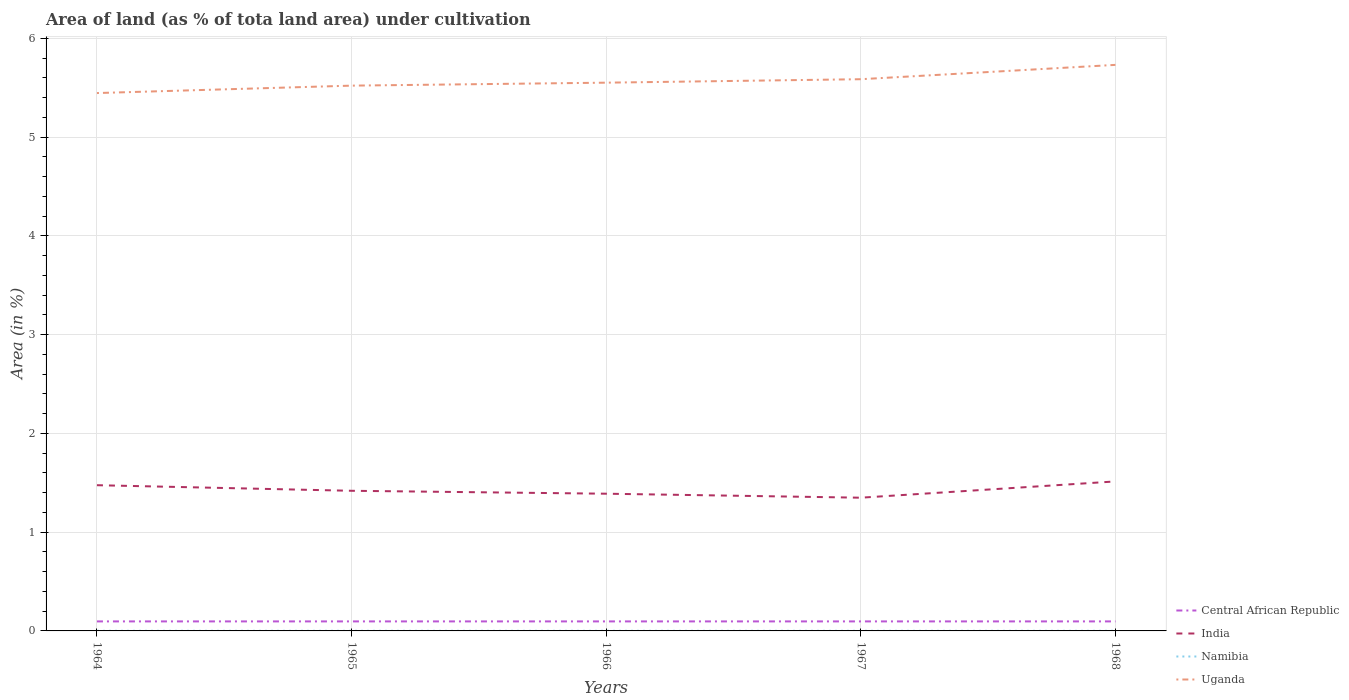Does the line corresponding to Central African Republic intersect with the line corresponding to Namibia?
Make the answer very short. No. Across all years, what is the maximum percentage of land under cultivation in Uganda?
Keep it short and to the point. 5.45. In which year was the percentage of land under cultivation in India maximum?
Give a very brief answer. 1967. What is the difference between the highest and the second highest percentage of land under cultivation in Namibia?
Provide a succinct answer. 0. Is the percentage of land under cultivation in Uganda strictly greater than the percentage of land under cultivation in Central African Republic over the years?
Provide a short and direct response. No. What is the difference between two consecutive major ticks on the Y-axis?
Your response must be concise. 1. Does the graph contain grids?
Ensure brevity in your answer.  Yes. How many legend labels are there?
Your answer should be very brief. 4. What is the title of the graph?
Your answer should be compact. Area of land (as % of tota land area) under cultivation. Does "Russian Federation" appear as one of the legend labels in the graph?
Provide a succinct answer. No. What is the label or title of the X-axis?
Provide a succinct answer. Years. What is the label or title of the Y-axis?
Offer a very short reply. Area (in %). What is the Area (in %) of Central African Republic in 1964?
Provide a succinct answer. 0.1. What is the Area (in %) of India in 1964?
Provide a short and direct response. 1.48. What is the Area (in %) in Namibia in 1964?
Your answer should be very brief. 0. What is the Area (in %) of Uganda in 1964?
Make the answer very short. 5.45. What is the Area (in %) in Central African Republic in 1965?
Offer a very short reply. 0.1. What is the Area (in %) of India in 1965?
Make the answer very short. 1.42. What is the Area (in %) in Namibia in 1965?
Provide a short and direct response. 0. What is the Area (in %) of Uganda in 1965?
Keep it short and to the point. 5.52. What is the Area (in %) in Central African Republic in 1966?
Offer a terse response. 0.1. What is the Area (in %) of India in 1966?
Provide a succinct answer. 1.39. What is the Area (in %) of Namibia in 1966?
Offer a terse response. 0. What is the Area (in %) in Uganda in 1966?
Offer a very short reply. 5.55. What is the Area (in %) of Central African Republic in 1967?
Give a very brief answer. 0.1. What is the Area (in %) in India in 1967?
Offer a terse response. 1.35. What is the Area (in %) of Namibia in 1967?
Make the answer very short. 0. What is the Area (in %) in Uganda in 1967?
Provide a short and direct response. 5.59. What is the Area (in %) in Central African Republic in 1968?
Give a very brief answer. 0.1. What is the Area (in %) in India in 1968?
Keep it short and to the point. 1.51. What is the Area (in %) of Namibia in 1968?
Your answer should be compact. 0. What is the Area (in %) in Uganda in 1968?
Ensure brevity in your answer.  5.73. Across all years, what is the maximum Area (in %) of Central African Republic?
Ensure brevity in your answer.  0.1. Across all years, what is the maximum Area (in %) in India?
Ensure brevity in your answer.  1.51. Across all years, what is the maximum Area (in %) of Namibia?
Ensure brevity in your answer.  0. Across all years, what is the maximum Area (in %) of Uganda?
Give a very brief answer. 5.73. Across all years, what is the minimum Area (in %) in Central African Republic?
Offer a very short reply. 0.1. Across all years, what is the minimum Area (in %) in India?
Your response must be concise. 1.35. Across all years, what is the minimum Area (in %) in Namibia?
Make the answer very short. 0. Across all years, what is the minimum Area (in %) of Uganda?
Provide a succinct answer. 5.45. What is the total Area (in %) in Central African Republic in the graph?
Give a very brief answer. 0.48. What is the total Area (in %) in India in the graph?
Offer a terse response. 7.15. What is the total Area (in %) in Namibia in the graph?
Ensure brevity in your answer.  0.01. What is the total Area (in %) of Uganda in the graph?
Provide a short and direct response. 27.83. What is the difference between the Area (in %) of India in 1964 and that in 1965?
Your response must be concise. 0.06. What is the difference between the Area (in %) of Namibia in 1964 and that in 1965?
Your answer should be compact. 0. What is the difference between the Area (in %) in Uganda in 1964 and that in 1965?
Provide a short and direct response. -0.08. What is the difference between the Area (in %) of India in 1964 and that in 1966?
Make the answer very short. 0.09. What is the difference between the Area (in %) of Uganda in 1964 and that in 1966?
Offer a terse response. -0.11. What is the difference between the Area (in %) of Central African Republic in 1964 and that in 1967?
Your answer should be very brief. 0. What is the difference between the Area (in %) of India in 1964 and that in 1967?
Offer a very short reply. 0.13. What is the difference between the Area (in %) of Namibia in 1964 and that in 1967?
Offer a terse response. 0. What is the difference between the Area (in %) in Uganda in 1964 and that in 1967?
Make the answer very short. -0.14. What is the difference between the Area (in %) of India in 1964 and that in 1968?
Offer a very short reply. -0.04. What is the difference between the Area (in %) in Namibia in 1964 and that in 1968?
Provide a succinct answer. 0. What is the difference between the Area (in %) in Uganda in 1964 and that in 1968?
Keep it short and to the point. -0.29. What is the difference between the Area (in %) of Central African Republic in 1965 and that in 1966?
Make the answer very short. 0. What is the difference between the Area (in %) in India in 1965 and that in 1966?
Your response must be concise. 0.03. What is the difference between the Area (in %) in Uganda in 1965 and that in 1966?
Keep it short and to the point. -0.03. What is the difference between the Area (in %) of Central African Republic in 1965 and that in 1967?
Ensure brevity in your answer.  0. What is the difference between the Area (in %) in India in 1965 and that in 1967?
Provide a succinct answer. 0.07. What is the difference between the Area (in %) of Uganda in 1965 and that in 1967?
Give a very brief answer. -0.07. What is the difference between the Area (in %) of India in 1965 and that in 1968?
Make the answer very short. -0.09. What is the difference between the Area (in %) in Uganda in 1965 and that in 1968?
Make the answer very short. -0.21. What is the difference between the Area (in %) of India in 1966 and that in 1967?
Your answer should be very brief. 0.04. What is the difference between the Area (in %) of Namibia in 1966 and that in 1967?
Offer a terse response. 0. What is the difference between the Area (in %) in Uganda in 1966 and that in 1967?
Offer a terse response. -0.04. What is the difference between the Area (in %) in India in 1966 and that in 1968?
Offer a terse response. -0.12. What is the difference between the Area (in %) in Namibia in 1966 and that in 1968?
Offer a very short reply. 0. What is the difference between the Area (in %) of Uganda in 1966 and that in 1968?
Your answer should be very brief. -0.18. What is the difference between the Area (in %) in India in 1967 and that in 1968?
Ensure brevity in your answer.  -0.16. What is the difference between the Area (in %) of Namibia in 1967 and that in 1968?
Make the answer very short. 0. What is the difference between the Area (in %) of Uganda in 1967 and that in 1968?
Your response must be concise. -0.15. What is the difference between the Area (in %) of Central African Republic in 1964 and the Area (in %) of India in 1965?
Ensure brevity in your answer.  -1.32. What is the difference between the Area (in %) of Central African Republic in 1964 and the Area (in %) of Namibia in 1965?
Keep it short and to the point. 0.1. What is the difference between the Area (in %) in Central African Republic in 1964 and the Area (in %) in Uganda in 1965?
Your response must be concise. -5.42. What is the difference between the Area (in %) in India in 1964 and the Area (in %) in Namibia in 1965?
Keep it short and to the point. 1.47. What is the difference between the Area (in %) of India in 1964 and the Area (in %) of Uganda in 1965?
Keep it short and to the point. -4.05. What is the difference between the Area (in %) of Namibia in 1964 and the Area (in %) of Uganda in 1965?
Offer a terse response. -5.52. What is the difference between the Area (in %) of Central African Republic in 1964 and the Area (in %) of India in 1966?
Ensure brevity in your answer.  -1.29. What is the difference between the Area (in %) of Central African Republic in 1964 and the Area (in %) of Namibia in 1966?
Your answer should be very brief. 0.1. What is the difference between the Area (in %) of Central African Republic in 1964 and the Area (in %) of Uganda in 1966?
Ensure brevity in your answer.  -5.45. What is the difference between the Area (in %) in India in 1964 and the Area (in %) in Namibia in 1966?
Provide a succinct answer. 1.47. What is the difference between the Area (in %) in India in 1964 and the Area (in %) in Uganda in 1966?
Make the answer very short. -4.08. What is the difference between the Area (in %) in Namibia in 1964 and the Area (in %) in Uganda in 1966?
Provide a short and direct response. -5.55. What is the difference between the Area (in %) in Central African Republic in 1964 and the Area (in %) in India in 1967?
Your answer should be compact. -1.25. What is the difference between the Area (in %) of Central African Republic in 1964 and the Area (in %) of Namibia in 1967?
Keep it short and to the point. 0.1. What is the difference between the Area (in %) of Central African Republic in 1964 and the Area (in %) of Uganda in 1967?
Ensure brevity in your answer.  -5.49. What is the difference between the Area (in %) in India in 1964 and the Area (in %) in Namibia in 1967?
Make the answer very short. 1.47. What is the difference between the Area (in %) of India in 1964 and the Area (in %) of Uganda in 1967?
Your answer should be compact. -4.11. What is the difference between the Area (in %) in Namibia in 1964 and the Area (in %) in Uganda in 1967?
Your response must be concise. -5.58. What is the difference between the Area (in %) of Central African Republic in 1964 and the Area (in %) of India in 1968?
Give a very brief answer. -1.42. What is the difference between the Area (in %) of Central African Republic in 1964 and the Area (in %) of Namibia in 1968?
Provide a succinct answer. 0.1. What is the difference between the Area (in %) of Central African Republic in 1964 and the Area (in %) of Uganda in 1968?
Give a very brief answer. -5.63. What is the difference between the Area (in %) of India in 1964 and the Area (in %) of Namibia in 1968?
Your answer should be compact. 1.47. What is the difference between the Area (in %) of India in 1964 and the Area (in %) of Uganda in 1968?
Ensure brevity in your answer.  -4.26. What is the difference between the Area (in %) in Namibia in 1964 and the Area (in %) in Uganda in 1968?
Offer a very short reply. -5.73. What is the difference between the Area (in %) of Central African Republic in 1965 and the Area (in %) of India in 1966?
Offer a terse response. -1.29. What is the difference between the Area (in %) of Central African Republic in 1965 and the Area (in %) of Namibia in 1966?
Provide a short and direct response. 0.1. What is the difference between the Area (in %) in Central African Republic in 1965 and the Area (in %) in Uganda in 1966?
Offer a very short reply. -5.45. What is the difference between the Area (in %) of India in 1965 and the Area (in %) of Namibia in 1966?
Your answer should be compact. 1.42. What is the difference between the Area (in %) of India in 1965 and the Area (in %) of Uganda in 1966?
Your response must be concise. -4.13. What is the difference between the Area (in %) of Namibia in 1965 and the Area (in %) of Uganda in 1966?
Provide a succinct answer. -5.55. What is the difference between the Area (in %) of Central African Republic in 1965 and the Area (in %) of India in 1967?
Your answer should be compact. -1.25. What is the difference between the Area (in %) of Central African Republic in 1965 and the Area (in %) of Namibia in 1967?
Keep it short and to the point. 0.1. What is the difference between the Area (in %) of Central African Republic in 1965 and the Area (in %) of Uganda in 1967?
Offer a very short reply. -5.49. What is the difference between the Area (in %) of India in 1965 and the Area (in %) of Namibia in 1967?
Provide a succinct answer. 1.42. What is the difference between the Area (in %) in India in 1965 and the Area (in %) in Uganda in 1967?
Your answer should be compact. -4.17. What is the difference between the Area (in %) of Namibia in 1965 and the Area (in %) of Uganda in 1967?
Offer a very short reply. -5.58. What is the difference between the Area (in %) in Central African Republic in 1965 and the Area (in %) in India in 1968?
Provide a short and direct response. -1.42. What is the difference between the Area (in %) of Central African Republic in 1965 and the Area (in %) of Namibia in 1968?
Give a very brief answer. 0.1. What is the difference between the Area (in %) in Central African Republic in 1965 and the Area (in %) in Uganda in 1968?
Your answer should be very brief. -5.63. What is the difference between the Area (in %) in India in 1965 and the Area (in %) in Namibia in 1968?
Provide a succinct answer. 1.42. What is the difference between the Area (in %) in India in 1965 and the Area (in %) in Uganda in 1968?
Make the answer very short. -4.31. What is the difference between the Area (in %) of Namibia in 1965 and the Area (in %) of Uganda in 1968?
Make the answer very short. -5.73. What is the difference between the Area (in %) of Central African Republic in 1966 and the Area (in %) of India in 1967?
Your answer should be compact. -1.25. What is the difference between the Area (in %) in Central African Republic in 1966 and the Area (in %) in Namibia in 1967?
Provide a short and direct response. 0.1. What is the difference between the Area (in %) in Central African Republic in 1966 and the Area (in %) in Uganda in 1967?
Your answer should be very brief. -5.49. What is the difference between the Area (in %) in India in 1966 and the Area (in %) in Namibia in 1967?
Your answer should be very brief. 1.39. What is the difference between the Area (in %) in India in 1966 and the Area (in %) in Uganda in 1967?
Your answer should be very brief. -4.2. What is the difference between the Area (in %) of Namibia in 1966 and the Area (in %) of Uganda in 1967?
Provide a succinct answer. -5.58. What is the difference between the Area (in %) in Central African Republic in 1966 and the Area (in %) in India in 1968?
Make the answer very short. -1.42. What is the difference between the Area (in %) of Central African Republic in 1966 and the Area (in %) of Namibia in 1968?
Offer a terse response. 0.1. What is the difference between the Area (in %) in Central African Republic in 1966 and the Area (in %) in Uganda in 1968?
Ensure brevity in your answer.  -5.63. What is the difference between the Area (in %) in India in 1966 and the Area (in %) in Namibia in 1968?
Offer a terse response. 1.39. What is the difference between the Area (in %) in India in 1966 and the Area (in %) in Uganda in 1968?
Make the answer very short. -4.34. What is the difference between the Area (in %) of Namibia in 1966 and the Area (in %) of Uganda in 1968?
Your answer should be compact. -5.73. What is the difference between the Area (in %) of Central African Republic in 1967 and the Area (in %) of India in 1968?
Offer a very short reply. -1.42. What is the difference between the Area (in %) in Central African Republic in 1967 and the Area (in %) in Namibia in 1968?
Ensure brevity in your answer.  0.1. What is the difference between the Area (in %) of Central African Republic in 1967 and the Area (in %) of Uganda in 1968?
Your answer should be compact. -5.63. What is the difference between the Area (in %) of India in 1967 and the Area (in %) of Namibia in 1968?
Provide a short and direct response. 1.35. What is the difference between the Area (in %) in India in 1967 and the Area (in %) in Uganda in 1968?
Offer a terse response. -4.38. What is the difference between the Area (in %) in Namibia in 1967 and the Area (in %) in Uganda in 1968?
Your answer should be very brief. -5.73. What is the average Area (in %) in Central African Republic per year?
Offer a very short reply. 0.1. What is the average Area (in %) of India per year?
Make the answer very short. 1.43. What is the average Area (in %) of Namibia per year?
Offer a very short reply. 0. What is the average Area (in %) of Uganda per year?
Make the answer very short. 5.57. In the year 1964, what is the difference between the Area (in %) of Central African Republic and Area (in %) of India?
Make the answer very short. -1.38. In the year 1964, what is the difference between the Area (in %) of Central African Republic and Area (in %) of Namibia?
Provide a short and direct response. 0.1. In the year 1964, what is the difference between the Area (in %) in Central African Republic and Area (in %) in Uganda?
Your answer should be compact. -5.35. In the year 1964, what is the difference between the Area (in %) of India and Area (in %) of Namibia?
Ensure brevity in your answer.  1.47. In the year 1964, what is the difference between the Area (in %) in India and Area (in %) in Uganda?
Provide a short and direct response. -3.97. In the year 1964, what is the difference between the Area (in %) in Namibia and Area (in %) in Uganda?
Give a very brief answer. -5.44. In the year 1965, what is the difference between the Area (in %) of Central African Republic and Area (in %) of India?
Ensure brevity in your answer.  -1.32. In the year 1965, what is the difference between the Area (in %) in Central African Republic and Area (in %) in Namibia?
Your answer should be compact. 0.1. In the year 1965, what is the difference between the Area (in %) in Central African Republic and Area (in %) in Uganda?
Offer a terse response. -5.42. In the year 1965, what is the difference between the Area (in %) in India and Area (in %) in Namibia?
Keep it short and to the point. 1.42. In the year 1965, what is the difference between the Area (in %) in India and Area (in %) in Uganda?
Offer a terse response. -4.1. In the year 1965, what is the difference between the Area (in %) of Namibia and Area (in %) of Uganda?
Offer a terse response. -5.52. In the year 1966, what is the difference between the Area (in %) in Central African Republic and Area (in %) in India?
Ensure brevity in your answer.  -1.29. In the year 1966, what is the difference between the Area (in %) in Central African Republic and Area (in %) in Namibia?
Give a very brief answer. 0.1. In the year 1966, what is the difference between the Area (in %) in Central African Republic and Area (in %) in Uganda?
Your response must be concise. -5.45. In the year 1966, what is the difference between the Area (in %) of India and Area (in %) of Namibia?
Make the answer very short. 1.39. In the year 1966, what is the difference between the Area (in %) of India and Area (in %) of Uganda?
Provide a short and direct response. -4.16. In the year 1966, what is the difference between the Area (in %) in Namibia and Area (in %) in Uganda?
Your answer should be very brief. -5.55. In the year 1967, what is the difference between the Area (in %) in Central African Republic and Area (in %) in India?
Offer a very short reply. -1.25. In the year 1967, what is the difference between the Area (in %) in Central African Republic and Area (in %) in Namibia?
Your answer should be compact. 0.1. In the year 1967, what is the difference between the Area (in %) in Central African Republic and Area (in %) in Uganda?
Keep it short and to the point. -5.49. In the year 1967, what is the difference between the Area (in %) of India and Area (in %) of Namibia?
Make the answer very short. 1.35. In the year 1967, what is the difference between the Area (in %) of India and Area (in %) of Uganda?
Provide a short and direct response. -4.24. In the year 1967, what is the difference between the Area (in %) in Namibia and Area (in %) in Uganda?
Your answer should be compact. -5.58. In the year 1968, what is the difference between the Area (in %) in Central African Republic and Area (in %) in India?
Your answer should be compact. -1.42. In the year 1968, what is the difference between the Area (in %) of Central African Republic and Area (in %) of Namibia?
Make the answer very short. 0.1. In the year 1968, what is the difference between the Area (in %) in Central African Republic and Area (in %) in Uganda?
Provide a succinct answer. -5.63. In the year 1968, what is the difference between the Area (in %) of India and Area (in %) of Namibia?
Make the answer very short. 1.51. In the year 1968, what is the difference between the Area (in %) of India and Area (in %) of Uganda?
Your response must be concise. -4.22. In the year 1968, what is the difference between the Area (in %) of Namibia and Area (in %) of Uganda?
Give a very brief answer. -5.73. What is the ratio of the Area (in %) in Central African Republic in 1964 to that in 1965?
Ensure brevity in your answer.  1. What is the ratio of the Area (in %) of India in 1964 to that in 1965?
Offer a terse response. 1.04. What is the ratio of the Area (in %) of Uganda in 1964 to that in 1965?
Your answer should be compact. 0.99. What is the ratio of the Area (in %) of Central African Republic in 1964 to that in 1966?
Give a very brief answer. 1. What is the ratio of the Area (in %) in India in 1964 to that in 1966?
Keep it short and to the point. 1.06. What is the ratio of the Area (in %) of Uganda in 1964 to that in 1966?
Your answer should be compact. 0.98. What is the ratio of the Area (in %) of India in 1964 to that in 1967?
Your response must be concise. 1.09. What is the ratio of the Area (in %) in Namibia in 1964 to that in 1967?
Offer a very short reply. 1. What is the ratio of the Area (in %) of Uganda in 1964 to that in 1967?
Provide a succinct answer. 0.97. What is the ratio of the Area (in %) in Central African Republic in 1964 to that in 1968?
Provide a succinct answer. 1. What is the ratio of the Area (in %) of India in 1964 to that in 1968?
Provide a short and direct response. 0.97. What is the ratio of the Area (in %) of Namibia in 1964 to that in 1968?
Your answer should be very brief. 1. What is the ratio of the Area (in %) in Uganda in 1964 to that in 1968?
Your answer should be very brief. 0.95. What is the ratio of the Area (in %) of India in 1965 to that in 1966?
Provide a short and direct response. 1.02. What is the ratio of the Area (in %) in India in 1965 to that in 1967?
Ensure brevity in your answer.  1.05. What is the ratio of the Area (in %) of Uganda in 1965 to that in 1967?
Your response must be concise. 0.99. What is the ratio of the Area (in %) in Central African Republic in 1965 to that in 1968?
Your answer should be very brief. 1. What is the ratio of the Area (in %) in India in 1965 to that in 1968?
Give a very brief answer. 0.94. What is the ratio of the Area (in %) of Namibia in 1965 to that in 1968?
Ensure brevity in your answer.  1. What is the ratio of the Area (in %) in Uganda in 1965 to that in 1968?
Give a very brief answer. 0.96. What is the ratio of the Area (in %) in Central African Republic in 1966 to that in 1967?
Offer a terse response. 1. What is the ratio of the Area (in %) in India in 1966 to that in 1967?
Provide a succinct answer. 1.03. What is the ratio of the Area (in %) of India in 1966 to that in 1968?
Your answer should be very brief. 0.92. What is the ratio of the Area (in %) in Namibia in 1966 to that in 1968?
Keep it short and to the point. 1. What is the ratio of the Area (in %) in Uganda in 1966 to that in 1968?
Ensure brevity in your answer.  0.97. What is the ratio of the Area (in %) of India in 1967 to that in 1968?
Keep it short and to the point. 0.89. What is the ratio of the Area (in %) in Uganda in 1967 to that in 1968?
Make the answer very short. 0.97. What is the difference between the highest and the second highest Area (in %) in Central African Republic?
Give a very brief answer. 0. What is the difference between the highest and the second highest Area (in %) in India?
Offer a terse response. 0.04. What is the difference between the highest and the second highest Area (in %) in Uganda?
Your response must be concise. 0.15. What is the difference between the highest and the lowest Area (in %) in India?
Provide a succinct answer. 0.16. What is the difference between the highest and the lowest Area (in %) in Namibia?
Offer a very short reply. 0. What is the difference between the highest and the lowest Area (in %) in Uganda?
Give a very brief answer. 0.29. 